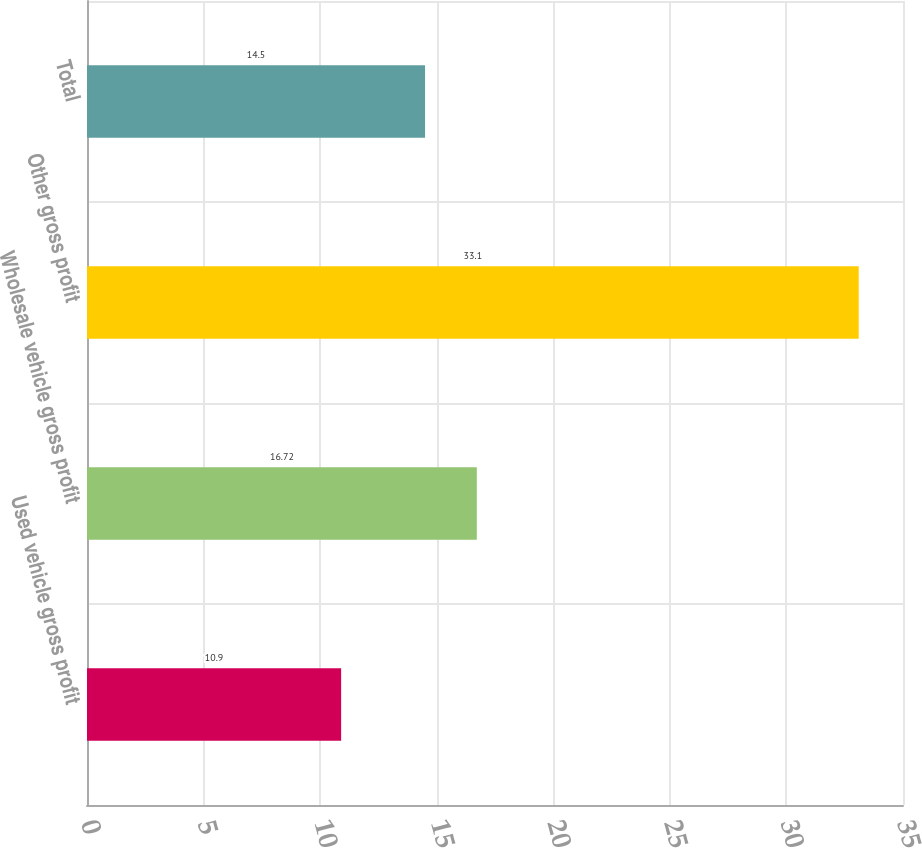Convert chart. <chart><loc_0><loc_0><loc_500><loc_500><bar_chart><fcel>Used vehicle gross profit<fcel>Wholesale vehicle gross profit<fcel>Other gross profit<fcel>Total<nl><fcel>10.9<fcel>16.72<fcel>33.1<fcel>14.5<nl></chart> 